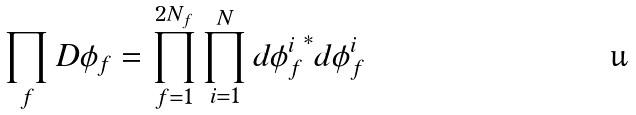Convert formula to latex. <formula><loc_0><loc_0><loc_500><loc_500>\prod _ { f } D \phi _ { f } = \prod _ { f = 1 } ^ { 2 N _ { f } } \prod _ { i = 1 } ^ { N } d { \phi _ { f } ^ { i } } ^ { * } d \phi _ { f } ^ { i }</formula> 